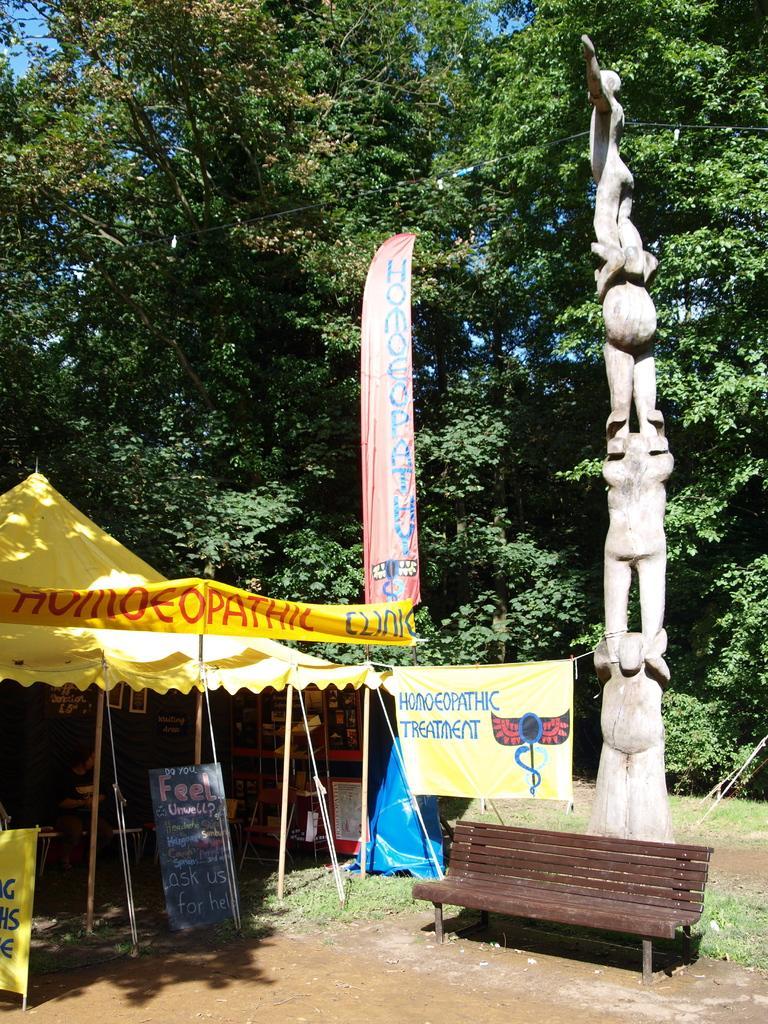Can you describe this image briefly? At the left side of image there is a tent inside there is a person sitting on the bench. There is a banner outside the tent. There is a statue at the right side of the image, before there is a bench. Background there are few trees. Right side it is a grassy land. 